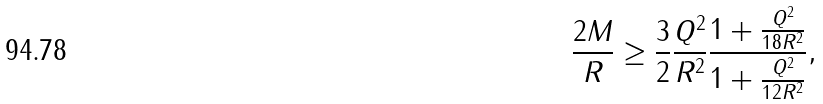<formula> <loc_0><loc_0><loc_500><loc_500>\frac { 2 M } { R } \geq \frac { 3 } { 2 } \frac { Q ^ { 2 } } { R ^ { 2 } } \frac { 1 + \frac { Q ^ { 2 } } { 1 8 R ^ { 2 } } } { 1 + \frac { Q ^ { 2 } } { 1 2 R ^ { 2 } } } ,</formula> 